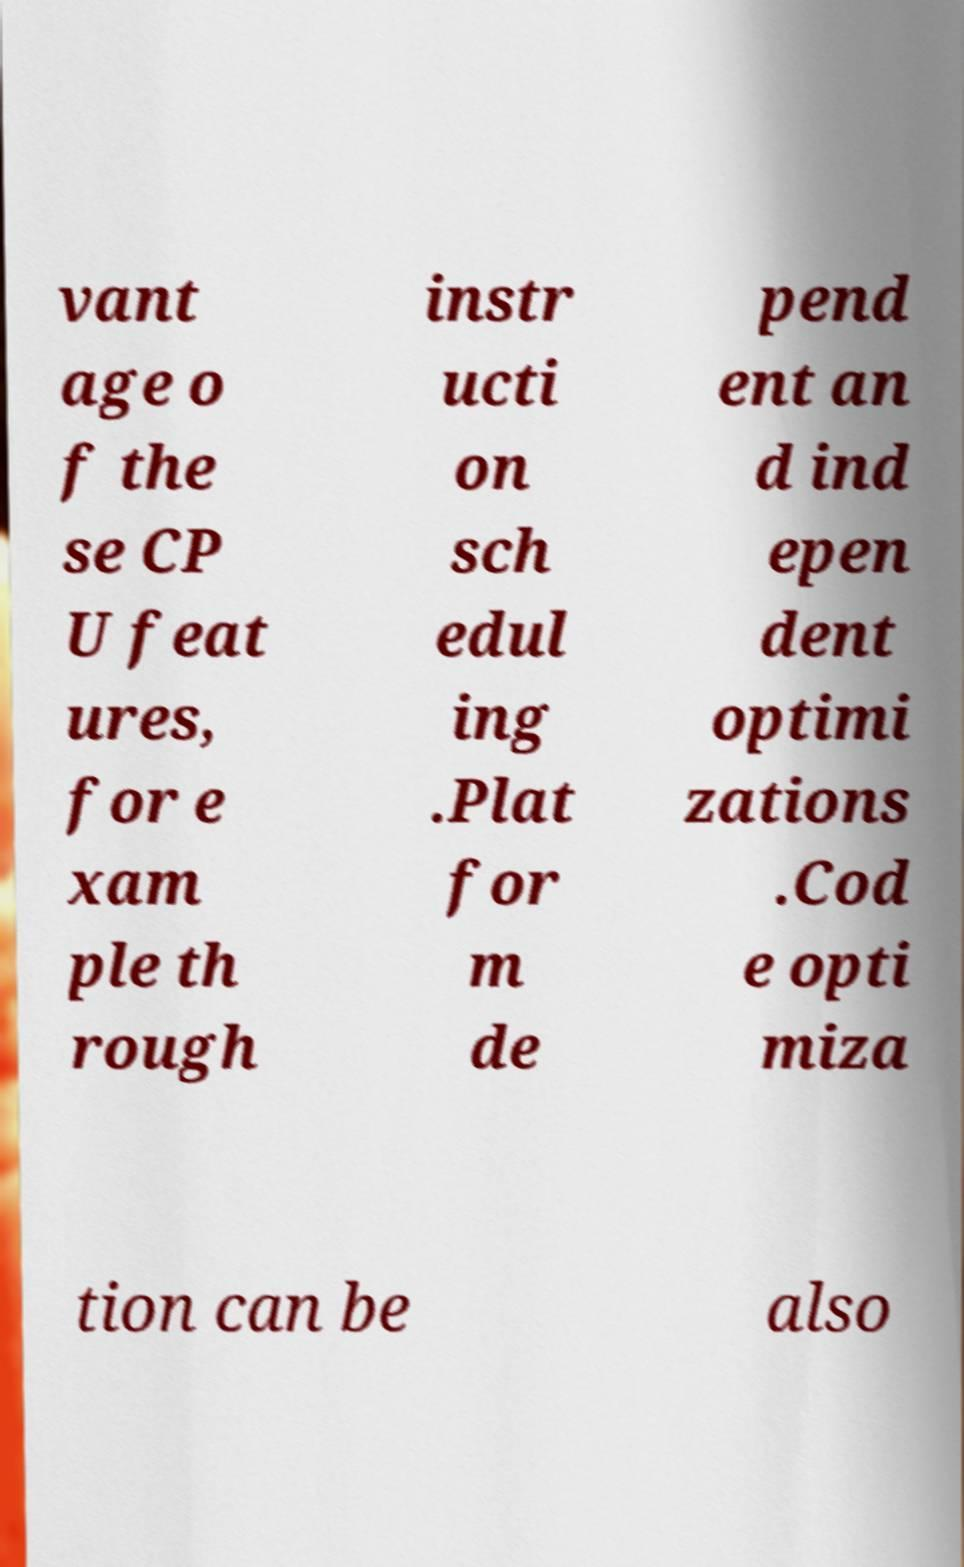Could you assist in decoding the text presented in this image and type it out clearly? vant age o f the se CP U feat ures, for e xam ple th rough instr ucti on sch edul ing .Plat for m de pend ent an d ind epen dent optimi zations .Cod e opti miza tion can be also 